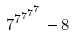Convert formula to latex. <formula><loc_0><loc_0><loc_500><loc_500>7 ^ { 7 ^ { 7 ^ { 7 ^ { 7 } } } } - 8</formula> 